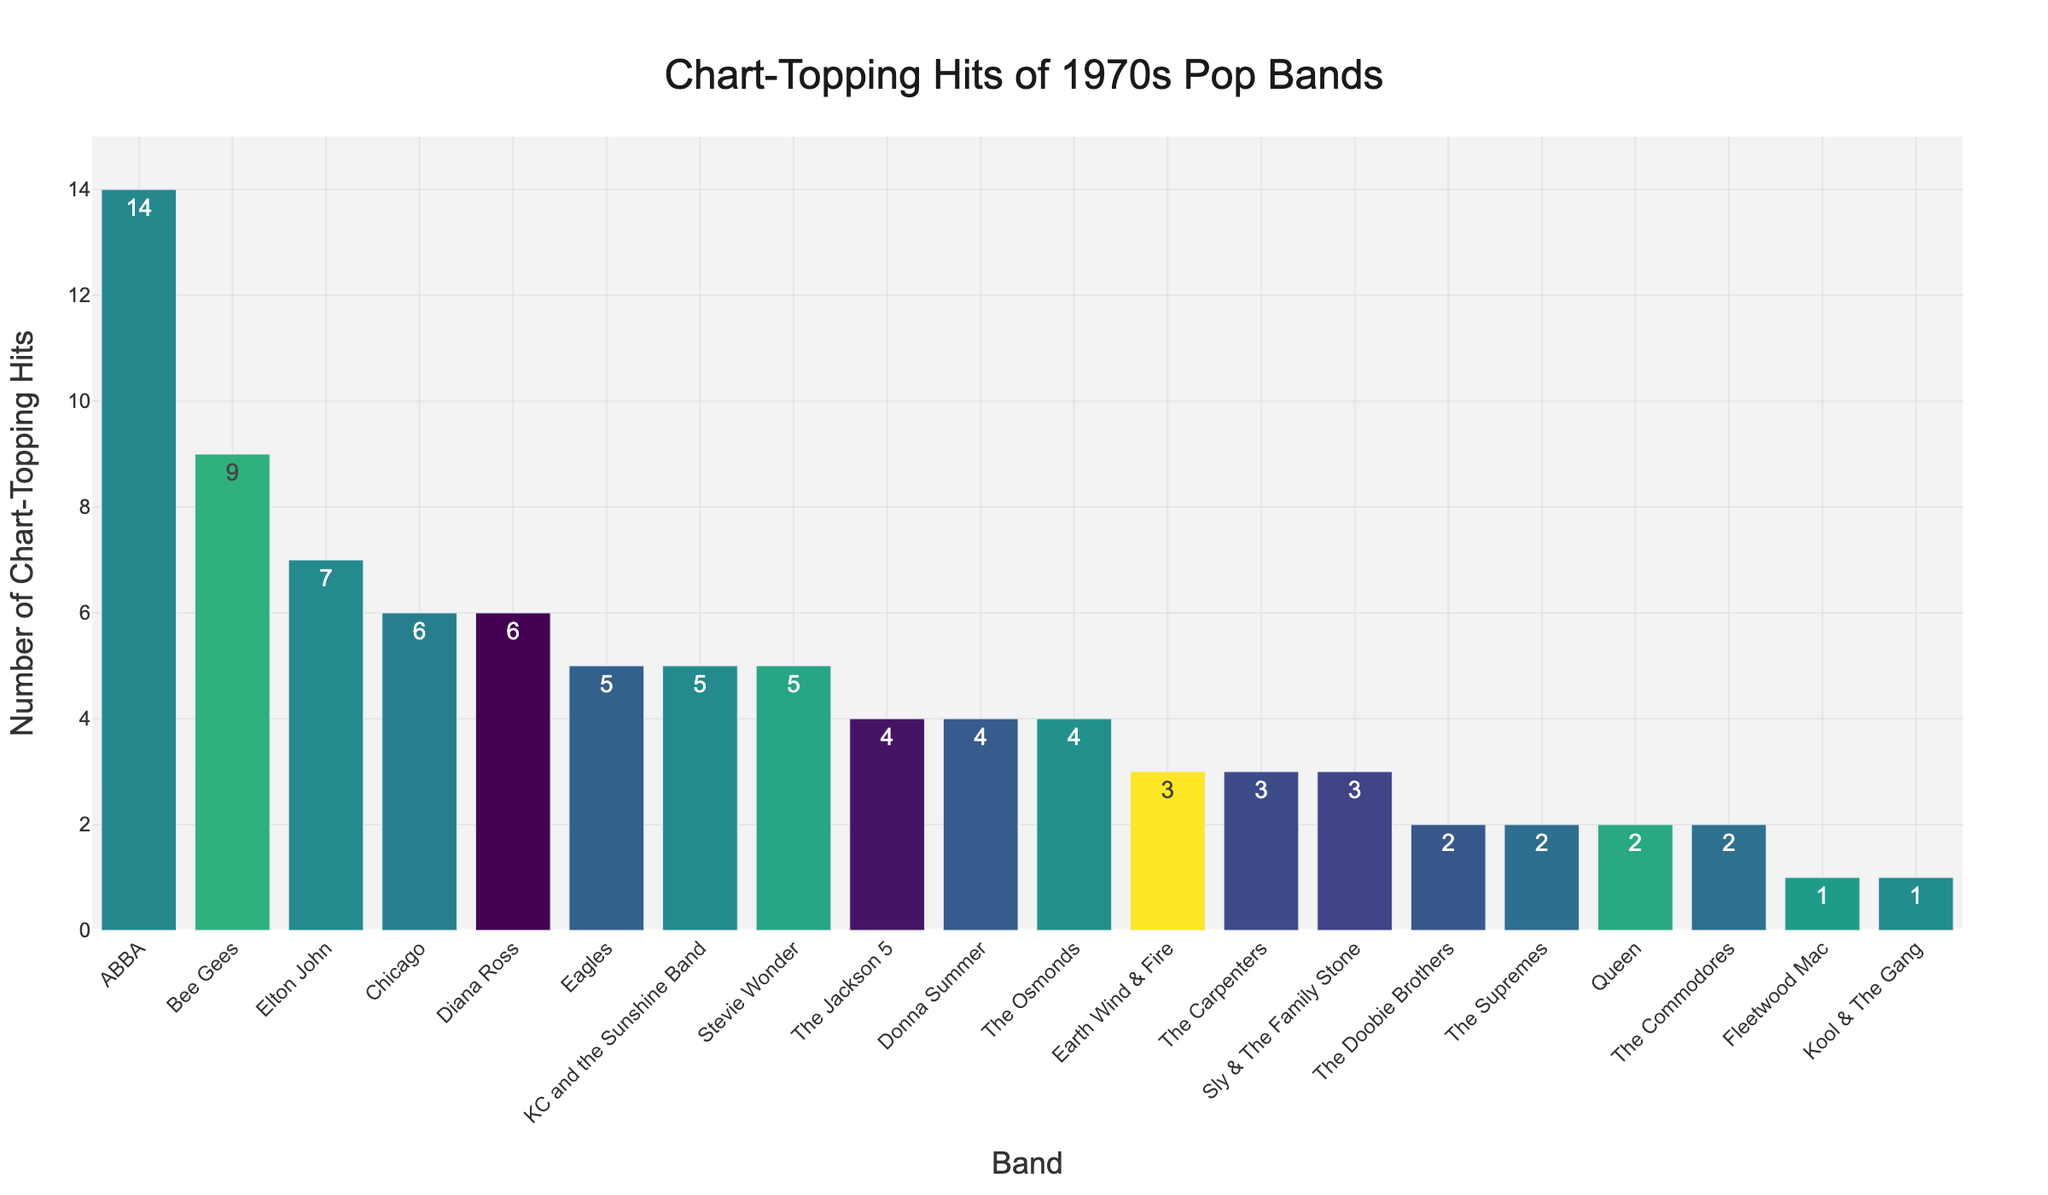Which band had the highest number of chart-topping hits in the 1970s? The highest bar represents the band with the most chart-topping hits. That bar corresponds to ABBA, which has a height of 14 hits.
Answer: ABBA How many more chart-topping hits did ABBA have compared to The Osmonds? ABBA had 14 hits and The Osmonds had 4 hits. Subtract the number of hits The Osmonds had from ABBA's hits: 14 - 4.
Answer: 10 Which bands had an equal number of chart-topping hits? The bands with equal heights in their bars denote equal hits. Both The Osmonds and The Jackson 5 have 4 hits each. Likewise, Queen, The Doobie Brothers, and The Commodores each have 2 hits.
Answer: The Osmonds and The Jackson 5; Queen, The Doobie Brothers, and The Commodores What is the total number of chart-topping hits for The Eagles, Elton John, Chicago, Diana Ross, and Stevie Wonder combined? Sum the number of hits for these artists: The Eagles (5), Elton John (7), Chicago (6), Diana Ross (6), Stevie Wonder (5). Thus, 5 + 7 + 6 + 6 + 5.
Answer: 29 How many bands had fewer than 3 chart-topping hits? Count the bars with heights less than 3. Fleetwood Mac, Queen, The Supremes, The Doobie Brothers, The Commodores, and Kool & The Gang each had less than 3 hits.
Answer: 6 Which band had the second-highest number of chart-topping hits? The second highest bar corresponds to the band with the second most hits, which is the Bee Gees with 9 hits.
Answer: Bee Gees What is the difference in chart-topping hits between the band with the most hits and the band with the least hits? The band with the most hits is ABBA (14 hits) and the band with the least hits is Kool & The Gang (1 hit). Subtract the least from the most: 14 - 1.
Answer: 13 How many chart-topping hits did The Jackson 5 and Donna Summer have in total? Add the number of hits for The Jackson 5 and Donna Summer: The Jackson 5 (4 hits) + Donna Summer (4 hits).
Answer: 8 Which bands had exactly 1 chart-topping hit? Identify the bars with height equal to 1. Both Fleetwood Mac and Kool & The Gang had 1 hit each.
Answer: Fleetwood Mac and Kool & The Gang 